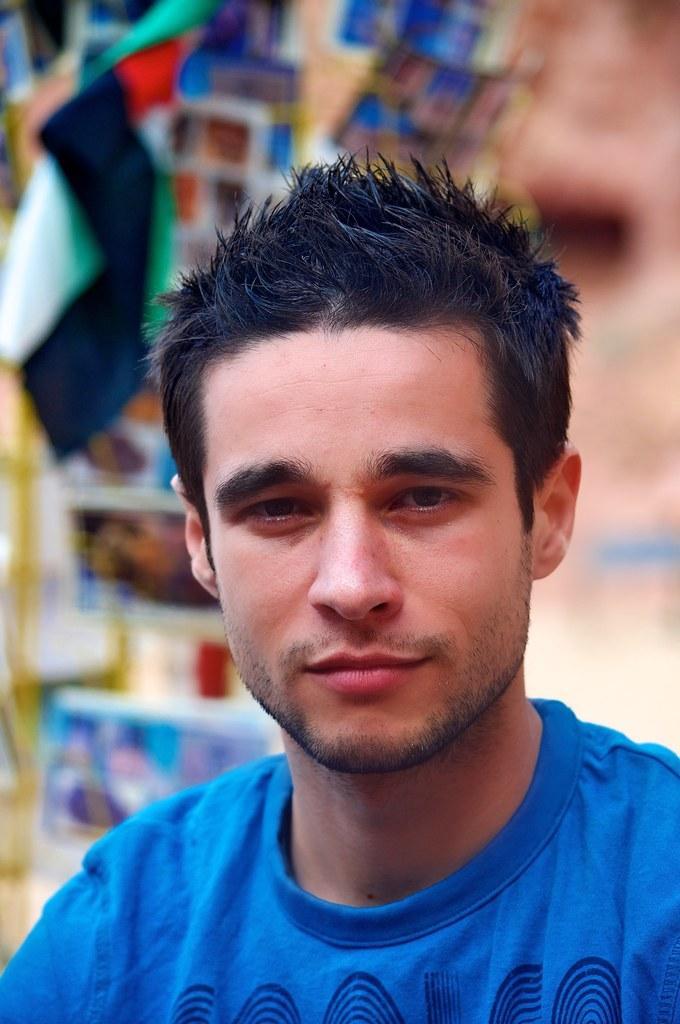Describe this image in one or two sentences. In the image we can see there is a man and he is wearing blue colour t shirt. Behind there is flag and the background of the image is blurred. 